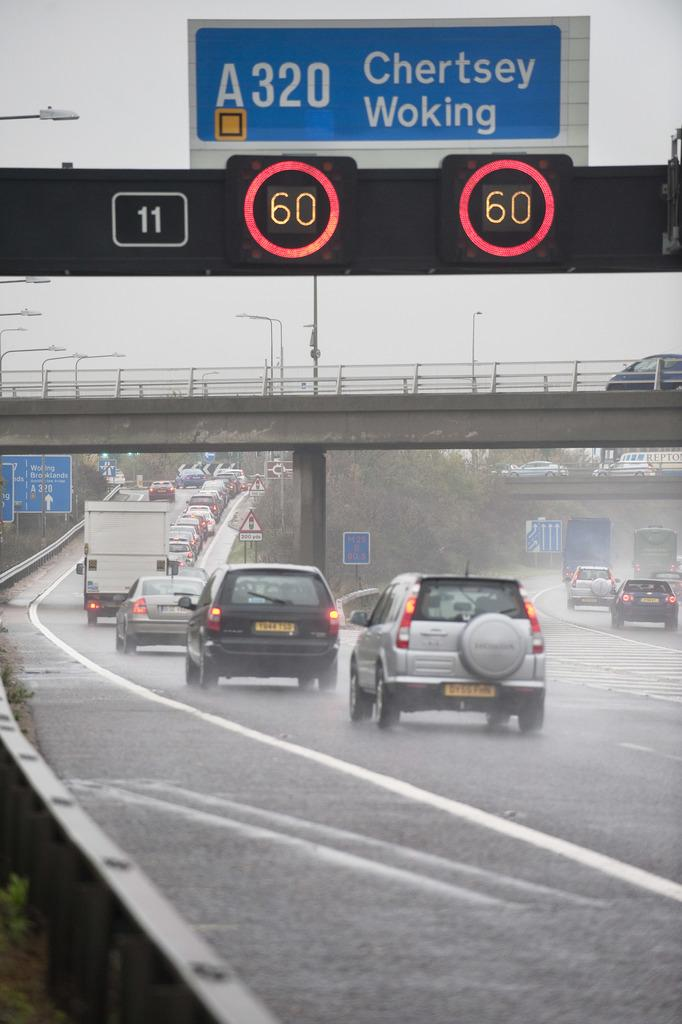What type of vehicles can be seen in the image? There are cars in the image. What are the vehicles doing in the image? The vehicles are moving on the freeway. What type of information is displayed on the sign boards in the image? The specific information on the sign boards is not mentioned, but they are present in the image. What device is used to display the speed of the vehicles? There is a speed display board in the image. What type of natural vegetation is visible in the image? There are trees in the image. What type of lighting is present along the freeway in the image? There are pole lights in the image. What is the weather condition in the image? The sky is cloudy in the image. What type of toys can be seen playing music in the image? There are no toys or music present in the image; it features cars and vehicles on a freeway. 